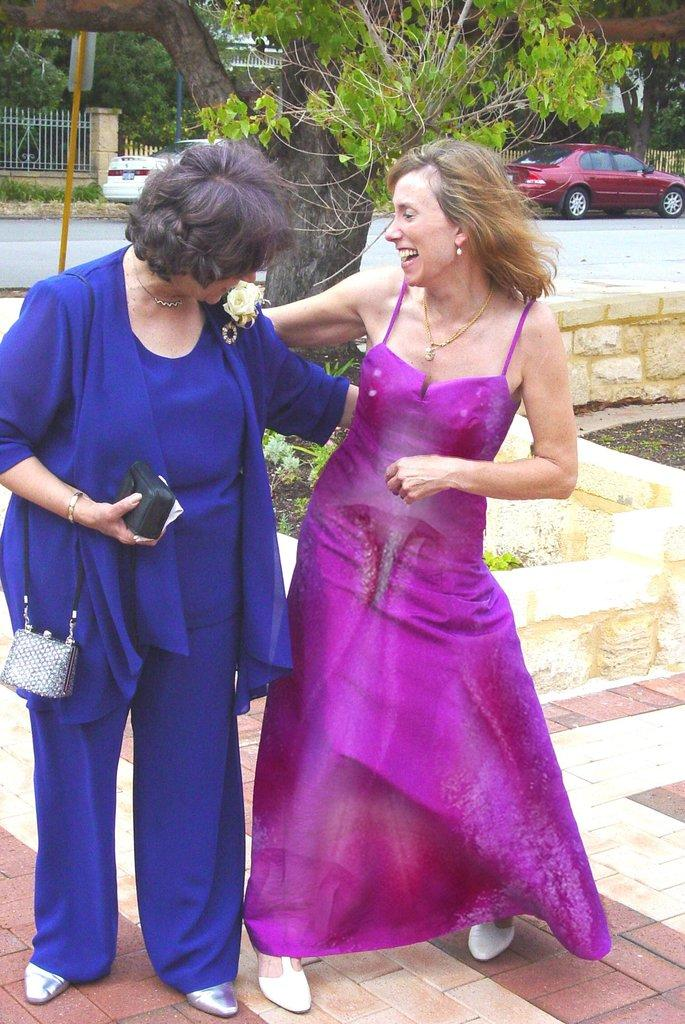What type of vegetation can be seen in the background of the image? There are trees in the background of the image. What architectural feature is present in the background of the image? There is a fence in the background of the image. What type of vehicles can be seen on the road in the image? There are cars on the road in the image. Who is present in the image? There are women standing in the image. What object can be seen in the image? There is a bag in the image. What type of vegetable is being sold in the store in the image? There is no store present in the image, and therefore no vegetables are being sold. What type of meat can be seen hanging from the fence in the image? There is no meat present in the image, and the fence is not associated with any food items. 